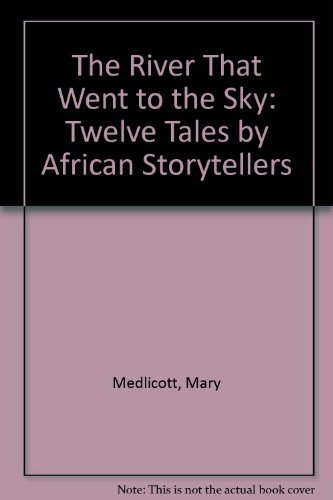Who wrote this book? This book, featuring a collection of twelve tales by African storytellers, was penned by Mary Medlicott. 